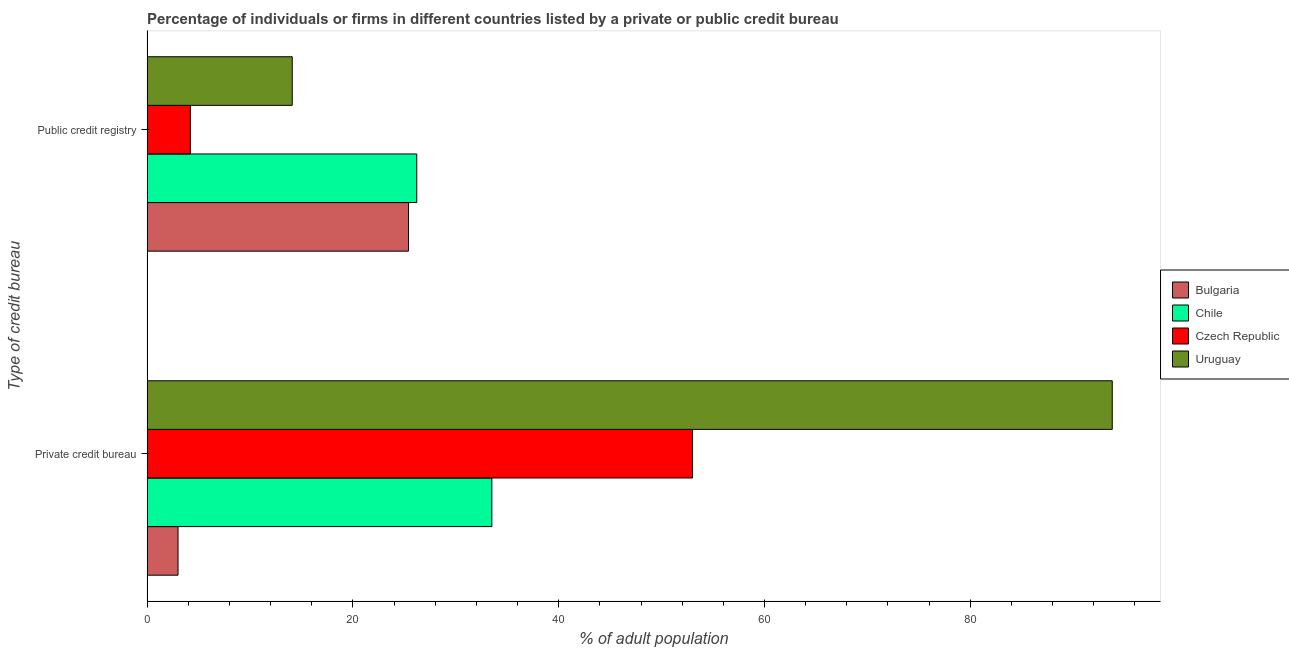How many different coloured bars are there?
Make the answer very short. 4. How many groups of bars are there?
Keep it short and to the point. 2. Are the number of bars per tick equal to the number of legend labels?
Your answer should be compact. Yes. How many bars are there on the 2nd tick from the bottom?
Give a very brief answer. 4. What is the label of the 2nd group of bars from the top?
Your answer should be compact. Private credit bureau. What is the percentage of firms listed by public credit bureau in Bulgaria?
Ensure brevity in your answer.  25.4. Across all countries, what is the maximum percentage of firms listed by public credit bureau?
Your answer should be compact. 26.2. Across all countries, what is the minimum percentage of firms listed by public credit bureau?
Your answer should be compact. 4.2. In which country was the percentage of firms listed by public credit bureau maximum?
Offer a terse response. Chile. What is the total percentage of firms listed by public credit bureau in the graph?
Ensure brevity in your answer.  69.9. What is the difference between the percentage of firms listed by private credit bureau in Chile and that in Czech Republic?
Offer a terse response. -19.5. What is the difference between the percentage of firms listed by private credit bureau in Chile and the percentage of firms listed by public credit bureau in Uruguay?
Keep it short and to the point. 19.4. What is the average percentage of firms listed by private credit bureau per country?
Give a very brief answer. 45.83. What is the difference between the percentage of firms listed by private credit bureau and percentage of firms listed by public credit bureau in Bulgaria?
Ensure brevity in your answer.  -22.4. In how many countries, is the percentage of firms listed by public credit bureau greater than 64 %?
Keep it short and to the point. 0. What is the ratio of the percentage of firms listed by private credit bureau in Chile to that in Bulgaria?
Your answer should be compact. 11.17. Is the percentage of firms listed by private credit bureau in Uruguay less than that in Czech Republic?
Provide a short and direct response. No. In how many countries, is the percentage of firms listed by private credit bureau greater than the average percentage of firms listed by private credit bureau taken over all countries?
Provide a succinct answer. 2. What does the 3rd bar from the bottom in Private credit bureau represents?
Keep it short and to the point. Czech Republic. How many bars are there?
Provide a succinct answer. 8. How many countries are there in the graph?
Your response must be concise. 4. Are the values on the major ticks of X-axis written in scientific E-notation?
Your answer should be very brief. No. Does the graph contain grids?
Offer a terse response. No. How are the legend labels stacked?
Give a very brief answer. Vertical. What is the title of the graph?
Your answer should be compact. Percentage of individuals or firms in different countries listed by a private or public credit bureau. Does "United Kingdom" appear as one of the legend labels in the graph?
Provide a succinct answer. No. What is the label or title of the X-axis?
Keep it short and to the point. % of adult population. What is the label or title of the Y-axis?
Offer a very short reply. Type of credit bureau. What is the % of adult population in Chile in Private credit bureau?
Your answer should be compact. 33.5. What is the % of adult population of Czech Republic in Private credit bureau?
Your response must be concise. 53. What is the % of adult population of Uruguay in Private credit bureau?
Provide a short and direct response. 93.8. What is the % of adult population in Bulgaria in Public credit registry?
Offer a terse response. 25.4. What is the % of adult population of Chile in Public credit registry?
Keep it short and to the point. 26.2. Across all Type of credit bureau, what is the maximum % of adult population in Bulgaria?
Offer a very short reply. 25.4. Across all Type of credit bureau, what is the maximum % of adult population of Chile?
Provide a short and direct response. 33.5. Across all Type of credit bureau, what is the maximum % of adult population of Czech Republic?
Give a very brief answer. 53. Across all Type of credit bureau, what is the maximum % of adult population in Uruguay?
Make the answer very short. 93.8. Across all Type of credit bureau, what is the minimum % of adult population in Chile?
Your answer should be compact. 26.2. Across all Type of credit bureau, what is the minimum % of adult population in Czech Republic?
Make the answer very short. 4.2. What is the total % of adult population of Bulgaria in the graph?
Make the answer very short. 28.4. What is the total % of adult population in Chile in the graph?
Make the answer very short. 59.7. What is the total % of adult population in Czech Republic in the graph?
Provide a short and direct response. 57.2. What is the total % of adult population in Uruguay in the graph?
Offer a terse response. 107.9. What is the difference between the % of adult population of Bulgaria in Private credit bureau and that in Public credit registry?
Make the answer very short. -22.4. What is the difference between the % of adult population of Chile in Private credit bureau and that in Public credit registry?
Keep it short and to the point. 7.3. What is the difference between the % of adult population in Czech Republic in Private credit bureau and that in Public credit registry?
Provide a short and direct response. 48.8. What is the difference between the % of adult population in Uruguay in Private credit bureau and that in Public credit registry?
Make the answer very short. 79.7. What is the difference between the % of adult population in Bulgaria in Private credit bureau and the % of adult population in Chile in Public credit registry?
Your answer should be compact. -23.2. What is the difference between the % of adult population of Bulgaria in Private credit bureau and the % of adult population of Czech Republic in Public credit registry?
Your answer should be very brief. -1.2. What is the difference between the % of adult population in Chile in Private credit bureau and the % of adult population in Czech Republic in Public credit registry?
Offer a very short reply. 29.3. What is the difference between the % of adult population of Czech Republic in Private credit bureau and the % of adult population of Uruguay in Public credit registry?
Provide a succinct answer. 38.9. What is the average % of adult population in Chile per Type of credit bureau?
Provide a succinct answer. 29.85. What is the average % of adult population in Czech Republic per Type of credit bureau?
Your answer should be very brief. 28.6. What is the average % of adult population of Uruguay per Type of credit bureau?
Ensure brevity in your answer.  53.95. What is the difference between the % of adult population in Bulgaria and % of adult population in Chile in Private credit bureau?
Provide a short and direct response. -30.5. What is the difference between the % of adult population in Bulgaria and % of adult population in Uruguay in Private credit bureau?
Offer a very short reply. -90.8. What is the difference between the % of adult population of Chile and % of adult population of Czech Republic in Private credit bureau?
Make the answer very short. -19.5. What is the difference between the % of adult population of Chile and % of adult population of Uruguay in Private credit bureau?
Ensure brevity in your answer.  -60.3. What is the difference between the % of adult population of Czech Republic and % of adult population of Uruguay in Private credit bureau?
Provide a short and direct response. -40.8. What is the difference between the % of adult population in Bulgaria and % of adult population in Czech Republic in Public credit registry?
Provide a succinct answer. 21.2. What is the difference between the % of adult population in Czech Republic and % of adult population in Uruguay in Public credit registry?
Your response must be concise. -9.9. What is the ratio of the % of adult population of Bulgaria in Private credit bureau to that in Public credit registry?
Provide a succinct answer. 0.12. What is the ratio of the % of adult population in Chile in Private credit bureau to that in Public credit registry?
Make the answer very short. 1.28. What is the ratio of the % of adult population of Czech Republic in Private credit bureau to that in Public credit registry?
Keep it short and to the point. 12.62. What is the ratio of the % of adult population of Uruguay in Private credit bureau to that in Public credit registry?
Make the answer very short. 6.65. What is the difference between the highest and the second highest % of adult population in Bulgaria?
Your answer should be very brief. 22.4. What is the difference between the highest and the second highest % of adult population in Czech Republic?
Keep it short and to the point. 48.8. What is the difference between the highest and the second highest % of adult population of Uruguay?
Give a very brief answer. 79.7. What is the difference between the highest and the lowest % of adult population of Bulgaria?
Your answer should be very brief. 22.4. What is the difference between the highest and the lowest % of adult population of Czech Republic?
Keep it short and to the point. 48.8. What is the difference between the highest and the lowest % of adult population of Uruguay?
Ensure brevity in your answer.  79.7. 